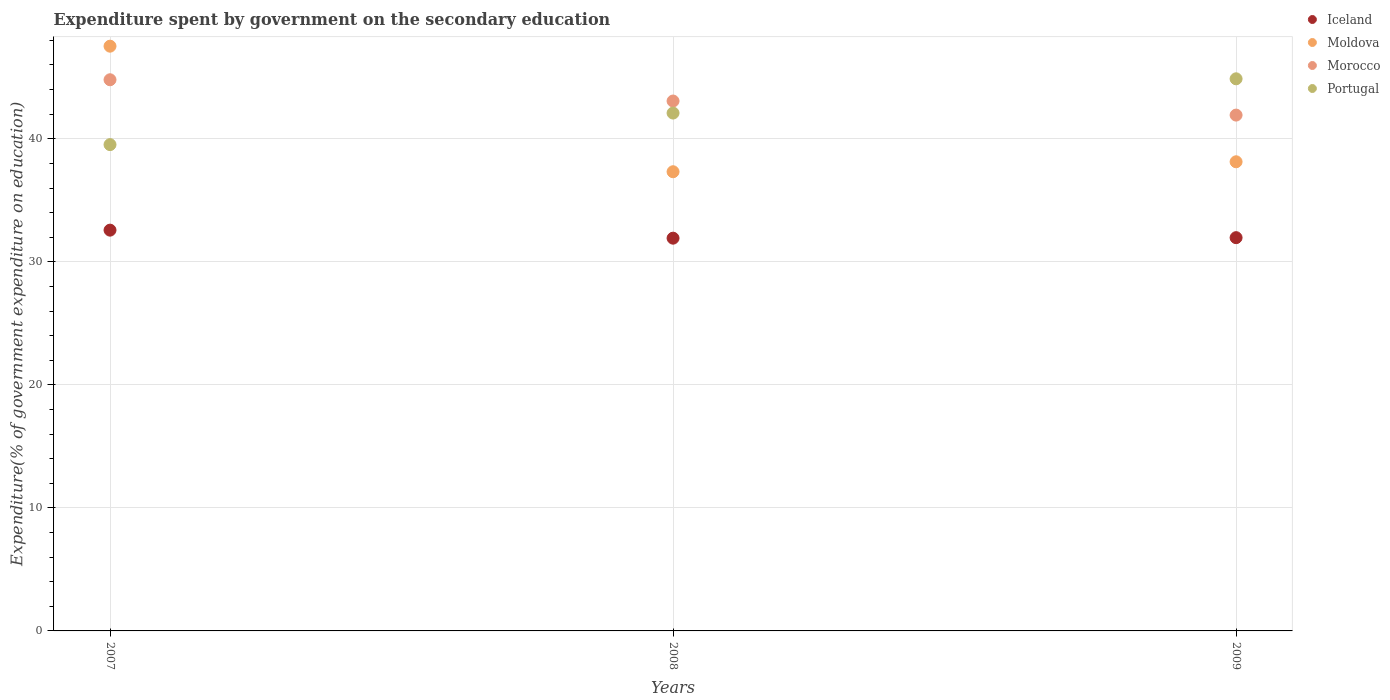How many different coloured dotlines are there?
Keep it short and to the point. 4. What is the expenditure spent by government on the secondary education in Moldova in 2009?
Ensure brevity in your answer.  38.13. Across all years, what is the maximum expenditure spent by government on the secondary education in Morocco?
Provide a succinct answer. 44.8. Across all years, what is the minimum expenditure spent by government on the secondary education in Portugal?
Provide a succinct answer. 39.53. In which year was the expenditure spent by government on the secondary education in Moldova minimum?
Your answer should be very brief. 2008. What is the total expenditure spent by government on the secondary education in Iceland in the graph?
Offer a very short reply. 96.46. What is the difference between the expenditure spent by government on the secondary education in Morocco in 2007 and that in 2008?
Your response must be concise. 1.73. What is the difference between the expenditure spent by government on the secondary education in Morocco in 2009 and the expenditure spent by government on the secondary education in Moldova in 2007?
Give a very brief answer. -5.6. What is the average expenditure spent by government on the secondary education in Morocco per year?
Your answer should be compact. 43.27. In the year 2009, what is the difference between the expenditure spent by government on the secondary education in Iceland and expenditure spent by government on the secondary education in Moldova?
Offer a very short reply. -6.17. What is the ratio of the expenditure spent by government on the secondary education in Iceland in 2007 to that in 2009?
Offer a terse response. 1.02. What is the difference between the highest and the second highest expenditure spent by government on the secondary education in Iceland?
Offer a terse response. 0.61. What is the difference between the highest and the lowest expenditure spent by government on the secondary education in Morocco?
Your answer should be very brief. 2.87. Is it the case that in every year, the sum of the expenditure spent by government on the secondary education in Morocco and expenditure spent by government on the secondary education in Moldova  is greater than the sum of expenditure spent by government on the secondary education in Iceland and expenditure spent by government on the secondary education in Portugal?
Give a very brief answer. Yes. Is it the case that in every year, the sum of the expenditure spent by government on the secondary education in Iceland and expenditure spent by government on the secondary education in Portugal  is greater than the expenditure spent by government on the secondary education in Moldova?
Provide a short and direct response. Yes. Does the expenditure spent by government on the secondary education in Morocco monotonically increase over the years?
Offer a very short reply. No. Is the expenditure spent by government on the secondary education in Iceland strictly less than the expenditure spent by government on the secondary education in Moldova over the years?
Make the answer very short. Yes. How many years are there in the graph?
Ensure brevity in your answer.  3. Are the values on the major ticks of Y-axis written in scientific E-notation?
Offer a very short reply. No. How are the legend labels stacked?
Provide a short and direct response. Vertical. What is the title of the graph?
Ensure brevity in your answer.  Expenditure spent by government on the secondary education. Does "Belarus" appear as one of the legend labels in the graph?
Keep it short and to the point. No. What is the label or title of the Y-axis?
Ensure brevity in your answer.  Expenditure(% of government expenditure on education). What is the Expenditure(% of government expenditure on education) of Iceland in 2007?
Make the answer very short. 32.58. What is the Expenditure(% of government expenditure on education) of Moldova in 2007?
Offer a terse response. 47.53. What is the Expenditure(% of government expenditure on education) of Morocco in 2007?
Offer a very short reply. 44.8. What is the Expenditure(% of government expenditure on education) in Portugal in 2007?
Provide a succinct answer. 39.53. What is the Expenditure(% of government expenditure on education) of Iceland in 2008?
Keep it short and to the point. 31.92. What is the Expenditure(% of government expenditure on education) of Moldova in 2008?
Ensure brevity in your answer.  37.32. What is the Expenditure(% of government expenditure on education) in Morocco in 2008?
Give a very brief answer. 43.07. What is the Expenditure(% of government expenditure on education) of Portugal in 2008?
Your answer should be compact. 42.09. What is the Expenditure(% of government expenditure on education) in Iceland in 2009?
Your answer should be very brief. 31.96. What is the Expenditure(% of government expenditure on education) of Moldova in 2009?
Offer a very short reply. 38.13. What is the Expenditure(% of government expenditure on education) in Morocco in 2009?
Ensure brevity in your answer.  41.93. What is the Expenditure(% of government expenditure on education) in Portugal in 2009?
Keep it short and to the point. 44.88. Across all years, what is the maximum Expenditure(% of government expenditure on education) in Iceland?
Provide a short and direct response. 32.58. Across all years, what is the maximum Expenditure(% of government expenditure on education) of Moldova?
Your answer should be very brief. 47.53. Across all years, what is the maximum Expenditure(% of government expenditure on education) of Morocco?
Make the answer very short. 44.8. Across all years, what is the maximum Expenditure(% of government expenditure on education) of Portugal?
Keep it short and to the point. 44.88. Across all years, what is the minimum Expenditure(% of government expenditure on education) in Iceland?
Your answer should be compact. 31.92. Across all years, what is the minimum Expenditure(% of government expenditure on education) in Moldova?
Keep it short and to the point. 37.32. Across all years, what is the minimum Expenditure(% of government expenditure on education) of Morocco?
Give a very brief answer. 41.93. Across all years, what is the minimum Expenditure(% of government expenditure on education) in Portugal?
Provide a succinct answer. 39.53. What is the total Expenditure(% of government expenditure on education) in Iceland in the graph?
Provide a succinct answer. 96.46. What is the total Expenditure(% of government expenditure on education) of Moldova in the graph?
Your response must be concise. 122.99. What is the total Expenditure(% of government expenditure on education) in Morocco in the graph?
Make the answer very short. 129.8. What is the total Expenditure(% of government expenditure on education) in Portugal in the graph?
Keep it short and to the point. 126.5. What is the difference between the Expenditure(% of government expenditure on education) of Iceland in 2007 and that in 2008?
Provide a short and direct response. 0.65. What is the difference between the Expenditure(% of government expenditure on education) of Moldova in 2007 and that in 2008?
Provide a short and direct response. 10.21. What is the difference between the Expenditure(% of government expenditure on education) in Morocco in 2007 and that in 2008?
Ensure brevity in your answer.  1.73. What is the difference between the Expenditure(% of government expenditure on education) of Portugal in 2007 and that in 2008?
Ensure brevity in your answer.  -2.56. What is the difference between the Expenditure(% of government expenditure on education) in Iceland in 2007 and that in 2009?
Provide a short and direct response. 0.61. What is the difference between the Expenditure(% of government expenditure on education) of Moldova in 2007 and that in 2009?
Ensure brevity in your answer.  9.4. What is the difference between the Expenditure(% of government expenditure on education) of Morocco in 2007 and that in 2009?
Your answer should be compact. 2.87. What is the difference between the Expenditure(% of government expenditure on education) of Portugal in 2007 and that in 2009?
Your answer should be compact. -5.35. What is the difference between the Expenditure(% of government expenditure on education) in Iceland in 2008 and that in 2009?
Provide a short and direct response. -0.04. What is the difference between the Expenditure(% of government expenditure on education) of Moldova in 2008 and that in 2009?
Your response must be concise. -0.81. What is the difference between the Expenditure(% of government expenditure on education) of Morocco in 2008 and that in 2009?
Give a very brief answer. 1.14. What is the difference between the Expenditure(% of government expenditure on education) of Portugal in 2008 and that in 2009?
Your answer should be compact. -2.78. What is the difference between the Expenditure(% of government expenditure on education) in Iceland in 2007 and the Expenditure(% of government expenditure on education) in Moldova in 2008?
Make the answer very short. -4.75. What is the difference between the Expenditure(% of government expenditure on education) of Iceland in 2007 and the Expenditure(% of government expenditure on education) of Morocco in 2008?
Your answer should be compact. -10.5. What is the difference between the Expenditure(% of government expenditure on education) in Iceland in 2007 and the Expenditure(% of government expenditure on education) in Portugal in 2008?
Your response must be concise. -9.52. What is the difference between the Expenditure(% of government expenditure on education) of Moldova in 2007 and the Expenditure(% of government expenditure on education) of Morocco in 2008?
Provide a short and direct response. 4.46. What is the difference between the Expenditure(% of government expenditure on education) in Moldova in 2007 and the Expenditure(% of government expenditure on education) in Portugal in 2008?
Give a very brief answer. 5.44. What is the difference between the Expenditure(% of government expenditure on education) in Morocco in 2007 and the Expenditure(% of government expenditure on education) in Portugal in 2008?
Your answer should be compact. 2.71. What is the difference between the Expenditure(% of government expenditure on education) of Iceland in 2007 and the Expenditure(% of government expenditure on education) of Moldova in 2009?
Give a very brief answer. -5.56. What is the difference between the Expenditure(% of government expenditure on education) in Iceland in 2007 and the Expenditure(% of government expenditure on education) in Morocco in 2009?
Your response must be concise. -9.35. What is the difference between the Expenditure(% of government expenditure on education) of Iceland in 2007 and the Expenditure(% of government expenditure on education) of Portugal in 2009?
Provide a succinct answer. -12.3. What is the difference between the Expenditure(% of government expenditure on education) in Moldova in 2007 and the Expenditure(% of government expenditure on education) in Morocco in 2009?
Give a very brief answer. 5.6. What is the difference between the Expenditure(% of government expenditure on education) in Moldova in 2007 and the Expenditure(% of government expenditure on education) in Portugal in 2009?
Offer a terse response. 2.65. What is the difference between the Expenditure(% of government expenditure on education) of Morocco in 2007 and the Expenditure(% of government expenditure on education) of Portugal in 2009?
Provide a succinct answer. -0.08. What is the difference between the Expenditure(% of government expenditure on education) of Iceland in 2008 and the Expenditure(% of government expenditure on education) of Moldova in 2009?
Ensure brevity in your answer.  -6.21. What is the difference between the Expenditure(% of government expenditure on education) of Iceland in 2008 and the Expenditure(% of government expenditure on education) of Morocco in 2009?
Your answer should be very brief. -10. What is the difference between the Expenditure(% of government expenditure on education) in Iceland in 2008 and the Expenditure(% of government expenditure on education) in Portugal in 2009?
Provide a succinct answer. -12.95. What is the difference between the Expenditure(% of government expenditure on education) in Moldova in 2008 and the Expenditure(% of government expenditure on education) in Morocco in 2009?
Offer a very short reply. -4.6. What is the difference between the Expenditure(% of government expenditure on education) in Moldova in 2008 and the Expenditure(% of government expenditure on education) in Portugal in 2009?
Provide a succinct answer. -7.55. What is the difference between the Expenditure(% of government expenditure on education) of Morocco in 2008 and the Expenditure(% of government expenditure on education) of Portugal in 2009?
Your answer should be very brief. -1.81. What is the average Expenditure(% of government expenditure on education) in Iceland per year?
Your answer should be very brief. 32.15. What is the average Expenditure(% of government expenditure on education) in Moldova per year?
Offer a terse response. 41. What is the average Expenditure(% of government expenditure on education) of Morocco per year?
Your answer should be very brief. 43.27. What is the average Expenditure(% of government expenditure on education) in Portugal per year?
Offer a terse response. 42.17. In the year 2007, what is the difference between the Expenditure(% of government expenditure on education) in Iceland and Expenditure(% of government expenditure on education) in Moldova?
Make the answer very short. -14.95. In the year 2007, what is the difference between the Expenditure(% of government expenditure on education) of Iceland and Expenditure(% of government expenditure on education) of Morocco?
Keep it short and to the point. -12.22. In the year 2007, what is the difference between the Expenditure(% of government expenditure on education) in Iceland and Expenditure(% of government expenditure on education) in Portugal?
Offer a terse response. -6.95. In the year 2007, what is the difference between the Expenditure(% of government expenditure on education) of Moldova and Expenditure(% of government expenditure on education) of Morocco?
Give a very brief answer. 2.73. In the year 2007, what is the difference between the Expenditure(% of government expenditure on education) of Moldova and Expenditure(% of government expenditure on education) of Portugal?
Make the answer very short. 8. In the year 2007, what is the difference between the Expenditure(% of government expenditure on education) in Morocco and Expenditure(% of government expenditure on education) in Portugal?
Provide a succinct answer. 5.27. In the year 2008, what is the difference between the Expenditure(% of government expenditure on education) of Iceland and Expenditure(% of government expenditure on education) of Moldova?
Give a very brief answer. -5.4. In the year 2008, what is the difference between the Expenditure(% of government expenditure on education) of Iceland and Expenditure(% of government expenditure on education) of Morocco?
Your response must be concise. -11.15. In the year 2008, what is the difference between the Expenditure(% of government expenditure on education) in Iceland and Expenditure(% of government expenditure on education) in Portugal?
Provide a short and direct response. -10.17. In the year 2008, what is the difference between the Expenditure(% of government expenditure on education) of Moldova and Expenditure(% of government expenditure on education) of Morocco?
Provide a succinct answer. -5.75. In the year 2008, what is the difference between the Expenditure(% of government expenditure on education) of Moldova and Expenditure(% of government expenditure on education) of Portugal?
Your response must be concise. -4.77. In the year 2008, what is the difference between the Expenditure(% of government expenditure on education) in Morocco and Expenditure(% of government expenditure on education) in Portugal?
Offer a terse response. 0.98. In the year 2009, what is the difference between the Expenditure(% of government expenditure on education) in Iceland and Expenditure(% of government expenditure on education) in Moldova?
Provide a short and direct response. -6.17. In the year 2009, what is the difference between the Expenditure(% of government expenditure on education) in Iceland and Expenditure(% of government expenditure on education) in Morocco?
Provide a short and direct response. -9.96. In the year 2009, what is the difference between the Expenditure(% of government expenditure on education) of Iceland and Expenditure(% of government expenditure on education) of Portugal?
Provide a succinct answer. -12.91. In the year 2009, what is the difference between the Expenditure(% of government expenditure on education) of Moldova and Expenditure(% of government expenditure on education) of Morocco?
Offer a very short reply. -3.79. In the year 2009, what is the difference between the Expenditure(% of government expenditure on education) of Moldova and Expenditure(% of government expenditure on education) of Portugal?
Offer a terse response. -6.74. In the year 2009, what is the difference between the Expenditure(% of government expenditure on education) of Morocco and Expenditure(% of government expenditure on education) of Portugal?
Provide a short and direct response. -2.95. What is the ratio of the Expenditure(% of government expenditure on education) of Iceland in 2007 to that in 2008?
Your answer should be very brief. 1.02. What is the ratio of the Expenditure(% of government expenditure on education) of Moldova in 2007 to that in 2008?
Your response must be concise. 1.27. What is the ratio of the Expenditure(% of government expenditure on education) of Morocco in 2007 to that in 2008?
Your response must be concise. 1.04. What is the ratio of the Expenditure(% of government expenditure on education) of Portugal in 2007 to that in 2008?
Offer a terse response. 0.94. What is the ratio of the Expenditure(% of government expenditure on education) in Iceland in 2007 to that in 2009?
Provide a succinct answer. 1.02. What is the ratio of the Expenditure(% of government expenditure on education) of Moldova in 2007 to that in 2009?
Your answer should be very brief. 1.25. What is the ratio of the Expenditure(% of government expenditure on education) of Morocco in 2007 to that in 2009?
Provide a short and direct response. 1.07. What is the ratio of the Expenditure(% of government expenditure on education) of Portugal in 2007 to that in 2009?
Provide a succinct answer. 0.88. What is the ratio of the Expenditure(% of government expenditure on education) of Moldova in 2008 to that in 2009?
Provide a short and direct response. 0.98. What is the ratio of the Expenditure(% of government expenditure on education) in Morocco in 2008 to that in 2009?
Ensure brevity in your answer.  1.03. What is the ratio of the Expenditure(% of government expenditure on education) in Portugal in 2008 to that in 2009?
Offer a very short reply. 0.94. What is the difference between the highest and the second highest Expenditure(% of government expenditure on education) in Iceland?
Give a very brief answer. 0.61. What is the difference between the highest and the second highest Expenditure(% of government expenditure on education) in Moldova?
Offer a terse response. 9.4. What is the difference between the highest and the second highest Expenditure(% of government expenditure on education) of Morocco?
Your response must be concise. 1.73. What is the difference between the highest and the second highest Expenditure(% of government expenditure on education) in Portugal?
Ensure brevity in your answer.  2.78. What is the difference between the highest and the lowest Expenditure(% of government expenditure on education) of Iceland?
Your response must be concise. 0.65. What is the difference between the highest and the lowest Expenditure(% of government expenditure on education) in Moldova?
Keep it short and to the point. 10.21. What is the difference between the highest and the lowest Expenditure(% of government expenditure on education) in Morocco?
Provide a short and direct response. 2.87. What is the difference between the highest and the lowest Expenditure(% of government expenditure on education) of Portugal?
Your response must be concise. 5.35. 